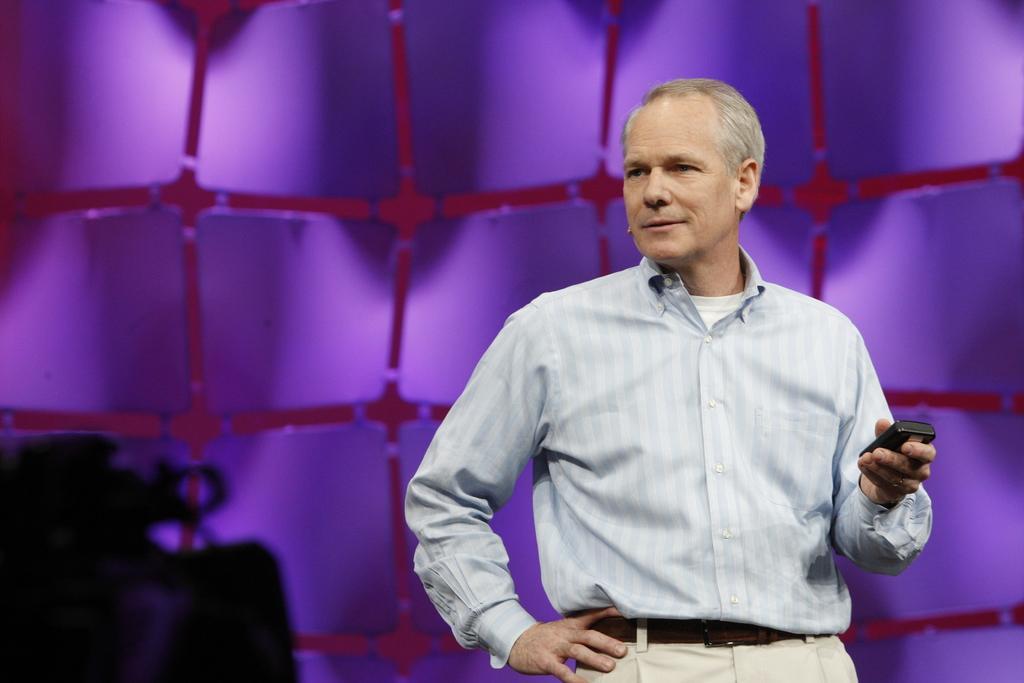Could you give a brief overview of what you see in this image? In this image we can see a person holding a device in his hand and wearing a microphone is standing. On the left side of the image we can see a camera. In the background, we can see a wall. 